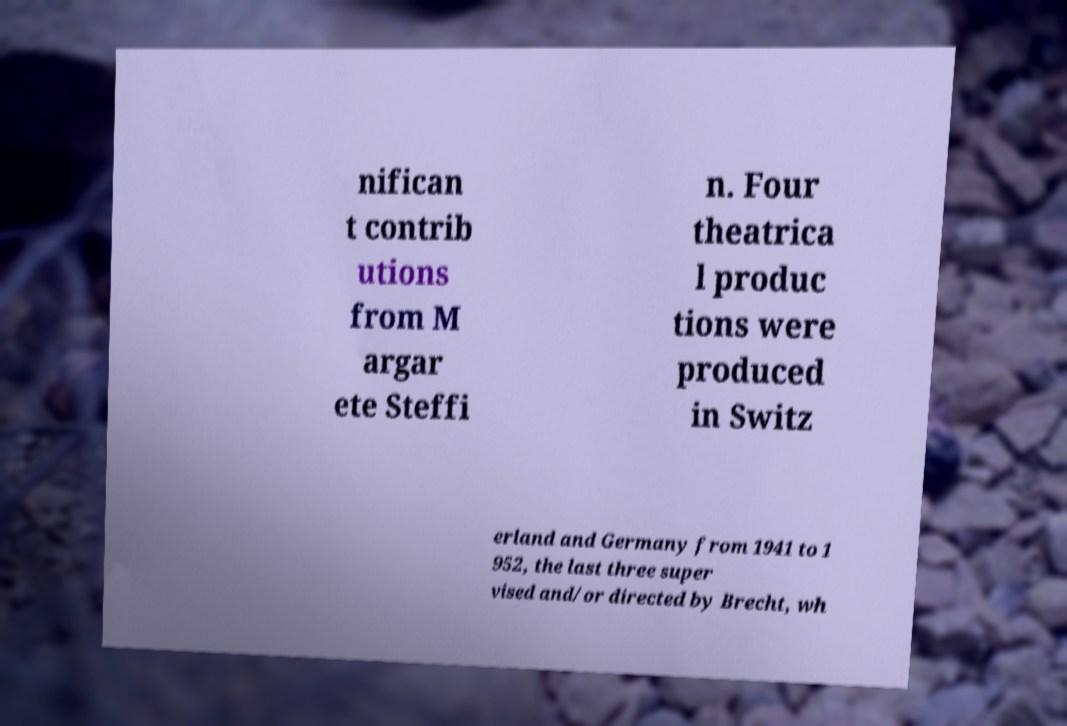Could you assist in decoding the text presented in this image and type it out clearly? nifican t contrib utions from M argar ete Steffi n. Four theatrica l produc tions were produced in Switz erland and Germany from 1941 to 1 952, the last three super vised and/or directed by Brecht, wh 